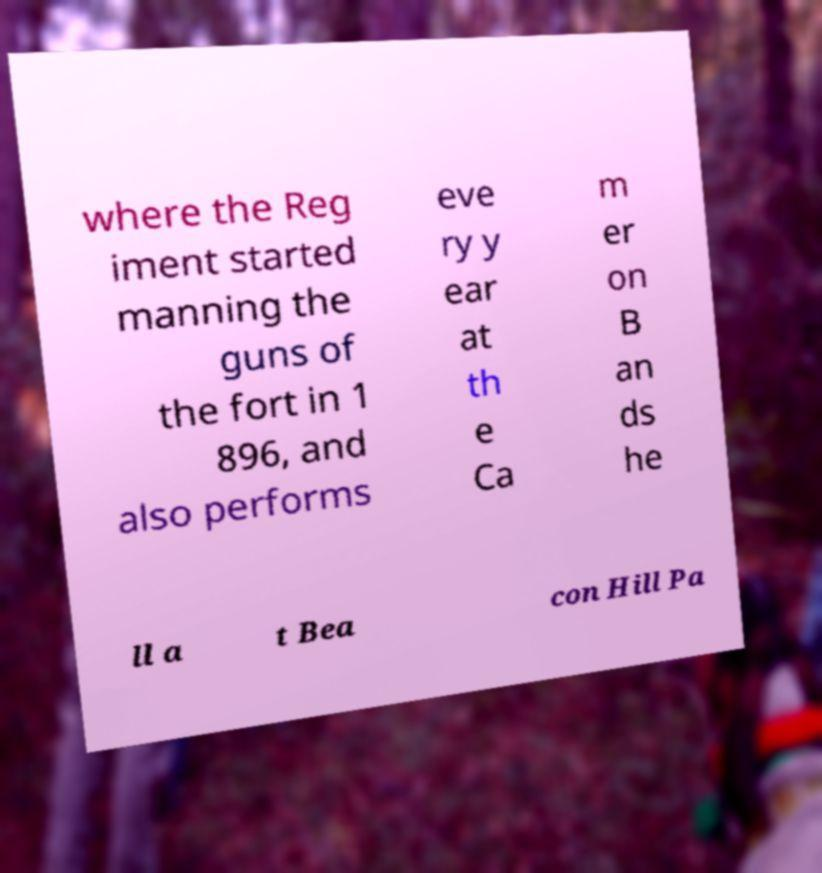Please identify and transcribe the text found in this image. where the Reg iment started manning the guns of the fort in 1 896, and also performs eve ry y ear at th e Ca m er on B an ds he ll a t Bea con Hill Pa 